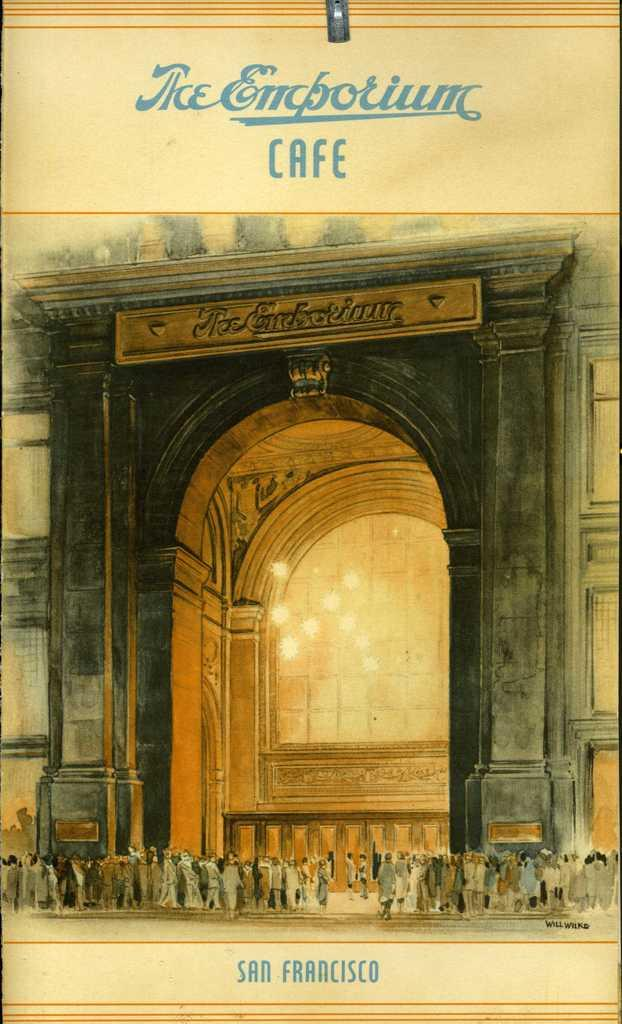What type of structure is depicted in the image? There is a picture of a building with an arch in the image. What additional feature can be seen in the image? There is a signboard in the image. What is the setting of the image? There are people standing on the surface in the image. Can you read any text in the image? There is some text visible in the image. How many pets are visible in the image? There are no pets present in the image. Are the people in the image crying? There is no indication in the image that the people are crying. 